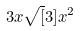<formula> <loc_0><loc_0><loc_500><loc_500>3 x \sqrt { [ } 3 ] { x ^ { 2 } }</formula> 